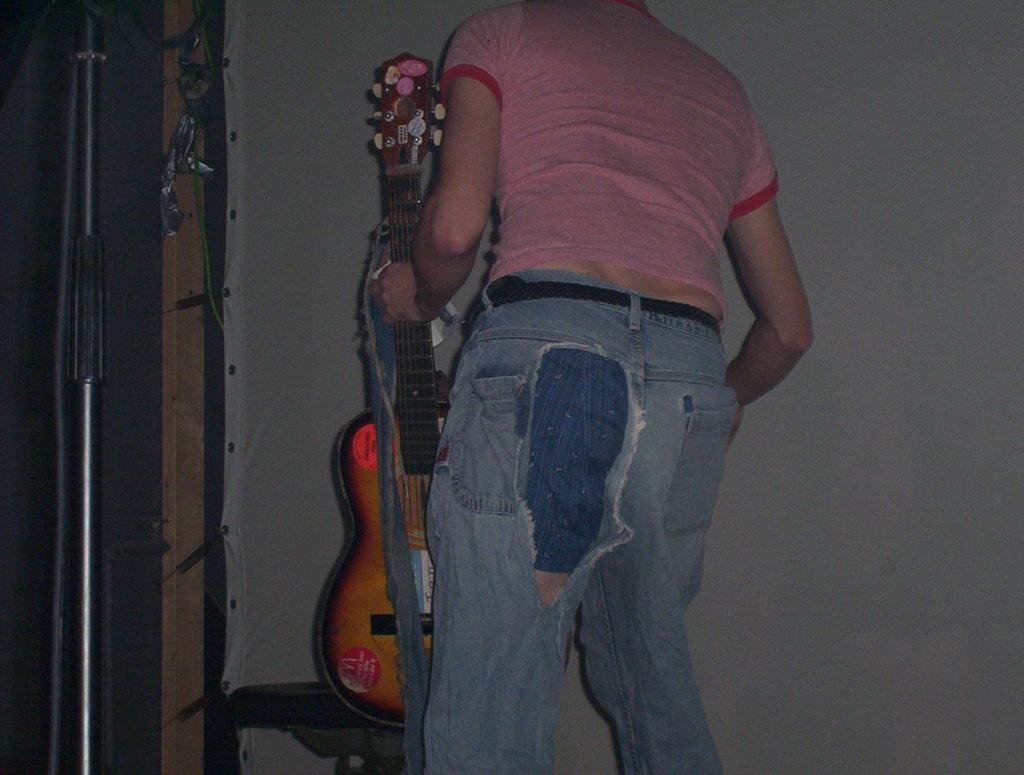Could you give a brief overview of what you see in this image? This person is standing and holds a guitar. This is a pole. This a white banner. 